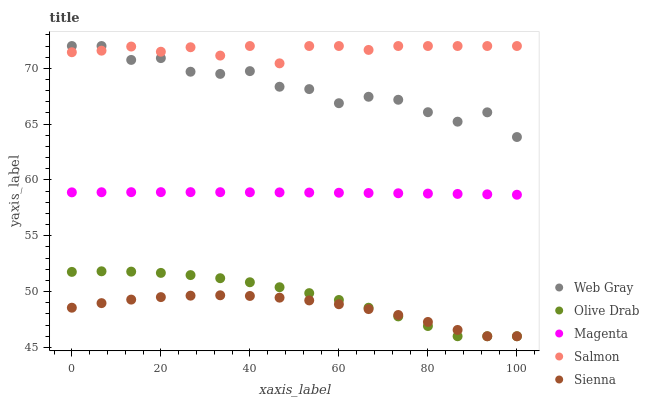Does Sienna have the minimum area under the curve?
Answer yes or no. Yes. Does Salmon have the maximum area under the curve?
Answer yes or no. Yes. Does Magenta have the minimum area under the curve?
Answer yes or no. No. Does Magenta have the maximum area under the curve?
Answer yes or no. No. Is Magenta the smoothest?
Answer yes or no. Yes. Is Web Gray the roughest?
Answer yes or no. Yes. Is Web Gray the smoothest?
Answer yes or no. No. Is Magenta the roughest?
Answer yes or no. No. Does Sienna have the lowest value?
Answer yes or no. Yes. Does Magenta have the lowest value?
Answer yes or no. No. Does Salmon have the highest value?
Answer yes or no. Yes. Does Magenta have the highest value?
Answer yes or no. No. Is Magenta less than Salmon?
Answer yes or no. Yes. Is Web Gray greater than Magenta?
Answer yes or no. Yes. Does Olive Drab intersect Sienna?
Answer yes or no. Yes. Is Olive Drab less than Sienna?
Answer yes or no. No. Is Olive Drab greater than Sienna?
Answer yes or no. No. Does Magenta intersect Salmon?
Answer yes or no. No. 